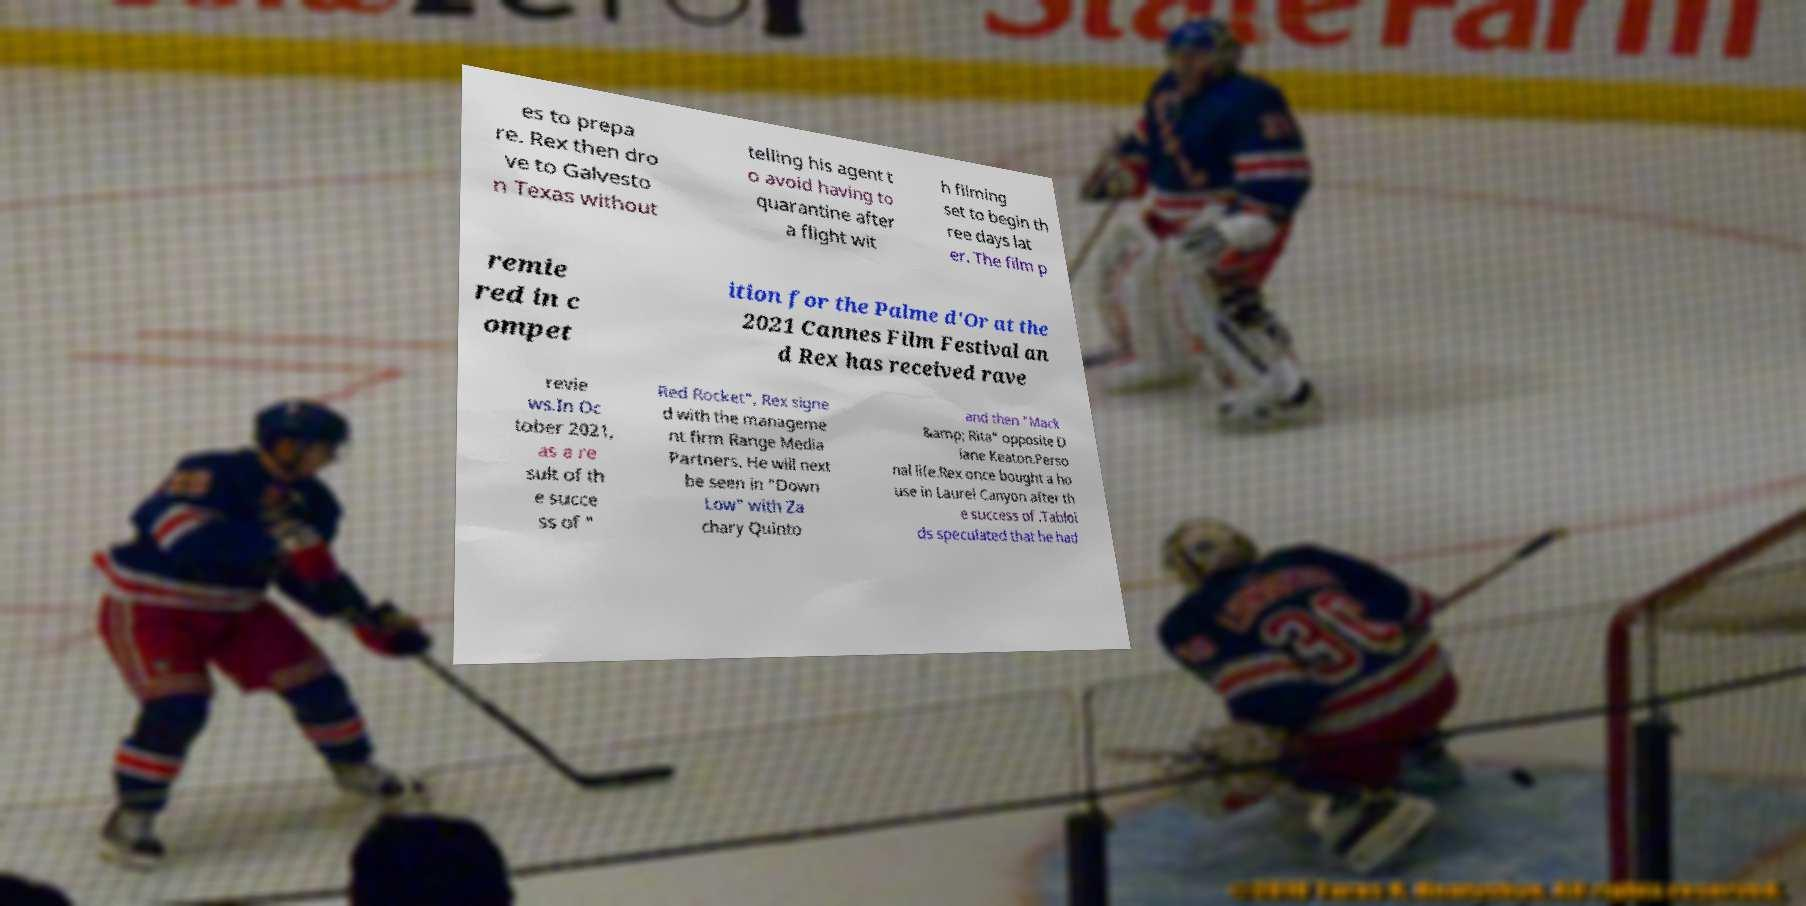What messages or text are displayed in this image? I need them in a readable, typed format. es to prepa re. Rex then dro ve to Galvesto n Texas without telling his agent t o avoid having to quarantine after a flight wit h filming set to begin th ree days lat er. The film p remie red in c ompet ition for the Palme d'Or at the 2021 Cannes Film Festival an d Rex has received rave revie ws.In Oc tober 2021, as a re sult of th e succe ss of " Red Rocket", Rex signe d with the manageme nt firm Range Media Partners. He will next be seen in "Down Low" with Za chary Quinto and then "Mack &amp; Rita" opposite D iane Keaton.Perso nal life.Rex once bought a ho use in Laurel Canyon after th e success of .Tabloi ds speculated that he had 